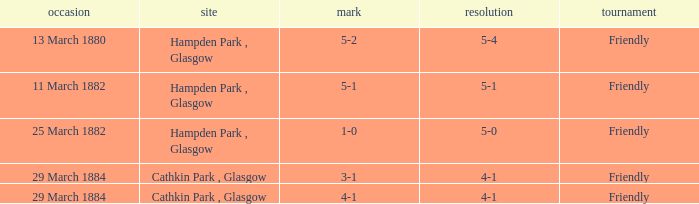Which competition had a 4-1 result, and a score of 4-1? Friendly. 